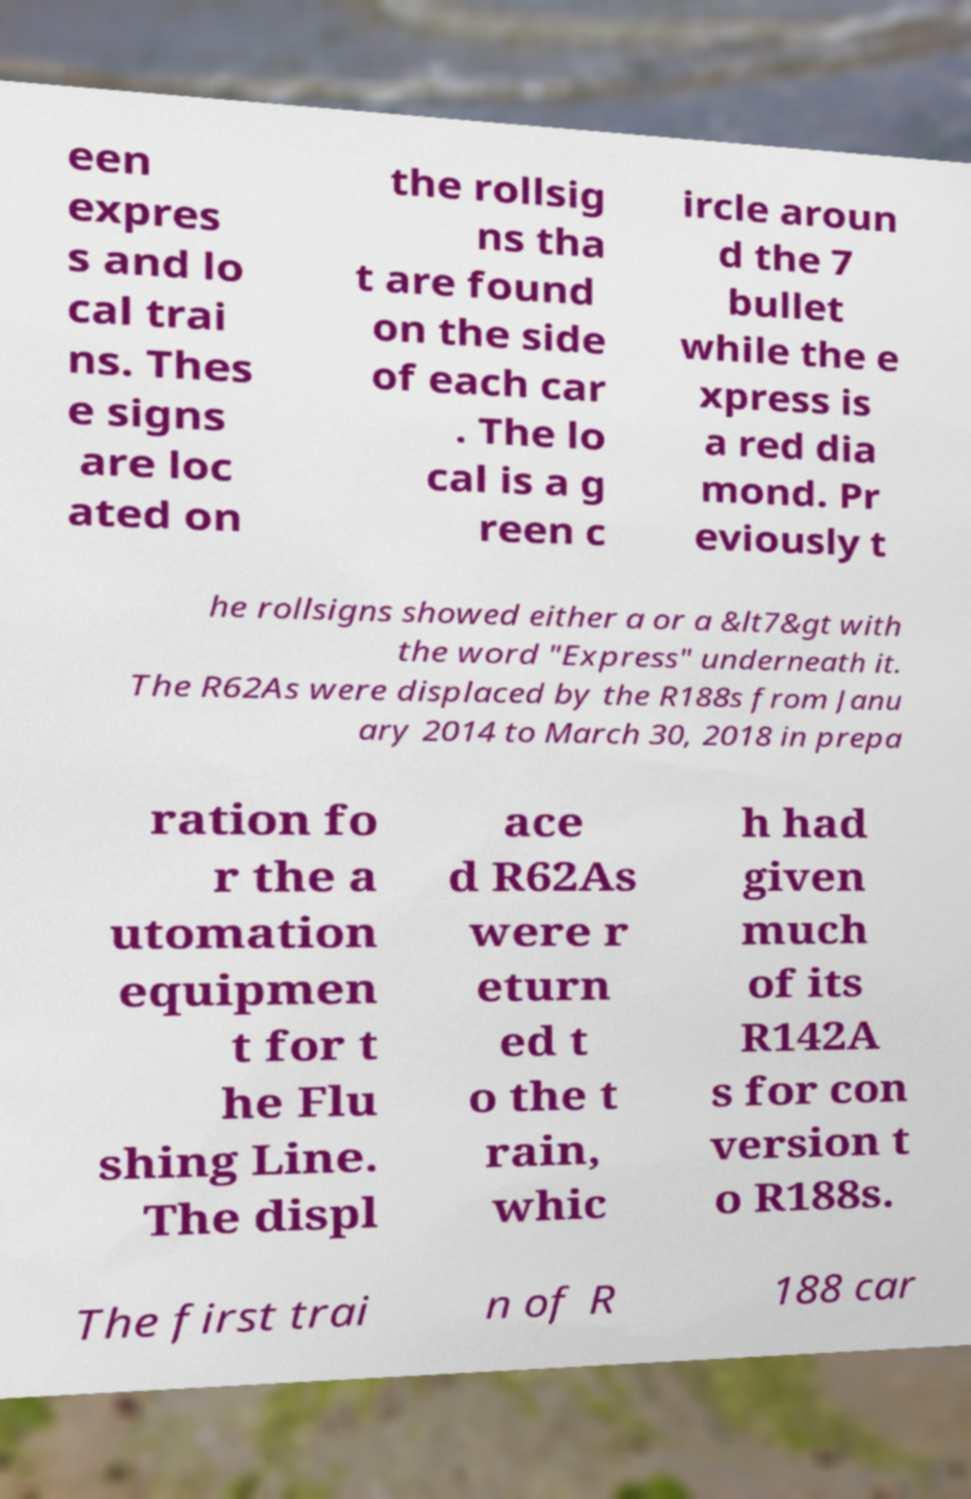For documentation purposes, I need the text within this image transcribed. Could you provide that? een expres s and lo cal trai ns. Thes e signs are loc ated on the rollsig ns tha t are found on the side of each car . The lo cal is a g reen c ircle aroun d the 7 bullet while the e xpress is a red dia mond. Pr eviously t he rollsigns showed either a or a &lt7&gt with the word "Express" underneath it. The R62As were displaced by the R188s from Janu ary 2014 to March 30, 2018 in prepa ration fo r the a utomation equipmen t for t he Flu shing Line. The displ ace d R62As were r eturn ed t o the t rain, whic h had given much of its R142A s for con version t o R188s. The first trai n of R 188 car 